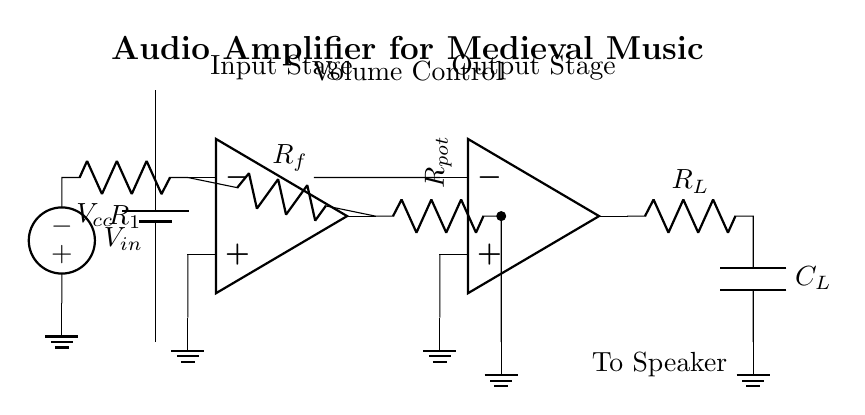What is the role of the op-amp in this circuit? The operational amplifier (op-amp) amplifies the input audio signal to a higher voltage suitable for driving a speaker. It does this by taking the input signal and increasing its amplitude based on the feedback provided by the resistors.
Answer: Amplification What is the purpose of the resistor labeled R_f? The resistor R_f provides feedback from the output of the op-amp back to its inverting input. This feedback controls the gain of the amplifier, allowing for stable and controlled amplification of the audio signal.
Answer: Feedback control What component controls the volume in this circuit? The potentiometer labeled R_pot controls the volume by adjusting the resistance in the circuit, effectively modifying the amount of signal being sent to the output stage and therefore adjusting the volume level.
Answer: R_pot How many op-amps are used in the circuit? There are two operational amplifiers used in the circuit, with one in the input stage and another in the output stage, contributing to the amplification process.
Answer: Two What happens to the audio signal after the output stage? After the output stage, the audio signal is sent to the speaker where it is converted back into sound. The capacitor C_L ensures better sound quality by filtering out unwanted noise.
Answer: Sent to speaker What is the overall purpose of this circuit? The overall purpose of this circuit is to amplify an audio signal for medieval-style music performances, making the music audible to a larger audience at the fair.
Answer: Audio amplification 